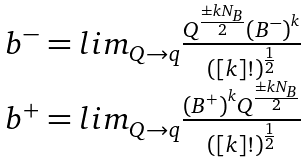Convert formula to latex. <formula><loc_0><loc_0><loc_500><loc_500>\begin{array} { c } { { b ^ { - } = l i m _ { Q \to q } { \frac { Q ^ { \frac { \pm k N _ { B } } { 2 } } { ( B ^ { - } ) } ^ { k } } { ( [ k ] ! ) ^ { \frac { 1 } { 2 } } } } } } \\ { { b ^ { + } = l i m _ { Q \to q } { { \frac { { ( B ^ { + } ) } ^ { k } Q ^ { { \frac { \pm k N _ { B } } { 2 } } } } { ( [ k ] ! ) ^ { \frac { 1 } { 2 } } } } } } } \end{array}</formula> 